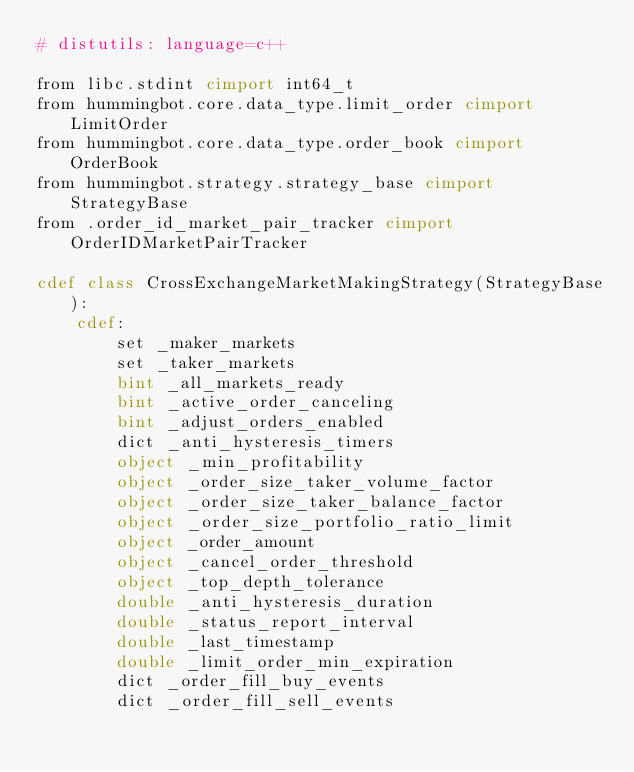Convert code to text. <code><loc_0><loc_0><loc_500><loc_500><_Cython_># distutils: language=c++

from libc.stdint cimport int64_t
from hummingbot.core.data_type.limit_order cimport LimitOrder
from hummingbot.core.data_type.order_book cimport OrderBook
from hummingbot.strategy.strategy_base cimport StrategyBase
from .order_id_market_pair_tracker cimport OrderIDMarketPairTracker

cdef class CrossExchangeMarketMakingStrategy(StrategyBase):
    cdef:
        set _maker_markets
        set _taker_markets
        bint _all_markets_ready
        bint _active_order_canceling
        bint _adjust_orders_enabled
        dict _anti_hysteresis_timers
        object _min_profitability
        object _order_size_taker_volume_factor
        object _order_size_taker_balance_factor
        object _order_size_portfolio_ratio_limit
        object _order_amount
        object _cancel_order_threshold
        object _top_depth_tolerance
        double _anti_hysteresis_duration
        double _status_report_interval
        double _last_timestamp
        double _limit_order_min_expiration
        dict _order_fill_buy_events
        dict _order_fill_sell_events</code> 